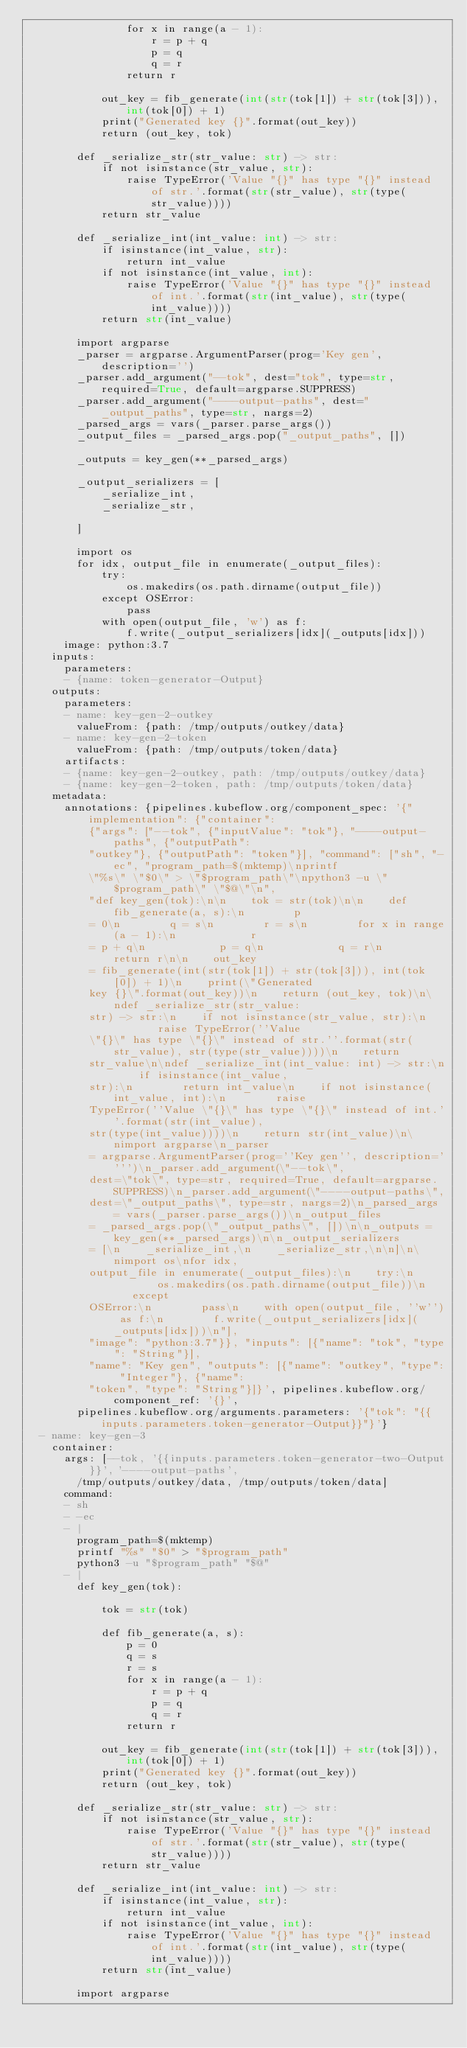Convert code to text. <code><loc_0><loc_0><loc_500><loc_500><_YAML_>                for x in range(a - 1):
                    r = p + q
                    p = q
                    q = r
                return r

            out_key = fib_generate(int(str(tok[1]) + str(tok[3])), int(tok[0]) + 1)
            print("Generated key {}".format(out_key))
            return (out_key, tok)

        def _serialize_str(str_value: str) -> str:
            if not isinstance(str_value, str):
                raise TypeError('Value "{}" has type "{}" instead of str.'.format(str(str_value), str(type(str_value))))
            return str_value

        def _serialize_int(int_value: int) -> str:
            if isinstance(int_value, str):
                return int_value
            if not isinstance(int_value, int):
                raise TypeError('Value "{}" has type "{}" instead of int.'.format(str(int_value), str(type(int_value))))
            return str(int_value)

        import argparse
        _parser = argparse.ArgumentParser(prog='Key gen', description='')
        _parser.add_argument("--tok", dest="tok", type=str, required=True, default=argparse.SUPPRESS)
        _parser.add_argument("----output-paths", dest="_output_paths", type=str, nargs=2)
        _parsed_args = vars(_parser.parse_args())
        _output_files = _parsed_args.pop("_output_paths", [])

        _outputs = key_gen(**_parsed_args)

        _output_serializers = [
            _serialize_int,
            _serialize_str,

        ]

        import os
        for idx, output_file in enumerate(_output_files):
            try:
                os.makedirs(os.path.dirname(output_file))
            except OSError:
                pass
            with open(output_file, 'w') as f:
                f.write(_output_serializers[idx](_outputs[idx]))
      image: python:3.7
    inputs:
      parameters:
      - {name: token-generator-Output}
    outputs:
      parameters:
      - name: key-gen-2-outkey
        valueFrom: {path: /tmp/outputs/outkey/data}
      - name: key-gen-2-token
        valueFrom: {path: /tmp/outputs/token/data}
      artifacts:
      - {name: key-gen-2-outkey, path: /tmp/outputs/outkey/data}
      - {name: key-gen-2-token, path: /tmp/outputs/token/data}
    metadata:
      annotations: {pipelines.kubeflow.org/component_spec: '{"implementation": {"container":
          {"args": ["--tok", {"inputValue": "tok"}, "----output-paths", {"outputPath":
          "outkey"}, {"outputPath": "token"}], "command": ["sh", "-ec", "program_path=$(mktemp)\nprintf
          \"%s\" \"$0\" > \"$program_path\"\npython3 -u \"$program_path\" \"$@\"\n",
          "def key_gen(tok):\n\n    tok = str(tok)\n\n    def fib_generate(a, s):\n        p
          = 0\n        q = s\n        r = s\n        for x in range(a - 1):\n            r
          = p + q\n            p = q\n            q = r\n        return r\n\n    out_key
          = fib_generate(int(str(tok[1]) + str(tok[3])), int(tok[0]) + 1)\n    print(\"Generated
          key {}\".format(out_key))\n    return (out_key, tok)\n\ndef _serialize_str(str_value:
          str) -> str:\n    if not isinstance(str_value, str):\n        raise TypeError(''Value
          \"{}\" has type \"{}\" instead of str.''.format(str(str_value), str(type(str_value))))\n    return
          str_value\n\ndef _serialize_int(int_value: int) -> str:\n    if isinstance(int_value,
          str):\n        return int_value\n    if not isinstance(int_value, int):\n        raise
          TypeError(''Value \"{}\" has type \"{}\" instead of int.''.format(str(int_value),
          str(type(int_value))))\n    return str(int_value)\n\nimport argparse\n_parser
          = argparse.ArgumentParser(prog=''Key gen'', description='''')\n_parser.add_argument(\"--tok\",
          dest=\"tok\", type=str, required=True, default=argparse.SUPPRESS)\n_parser.add_argument(\"----output-paths\",
          dest=\"_output_paths\", type=str, nargs=2)\n_parsed_args = vars(_parser.parse_args())\n_output_files
          = _parsed_args.pop(\"_output_paths\", [])\n\n_outputs = key_gen(**_parsed_args)\n\n_output_serializers
          = [\n    _serialize_int,\n    _serialize_str,\n\n]\n\nimport os\nfor idx,
          output_file in enumerate(_output_files):\n    try:\n        os.makedirs(os.path.dirname(output_file))\n    except
          OSError:\n        pass\n    with open(output_file, ''w'') as f:\n        f.write(_output_serializers[idx](_outputs[idx]))\n"],
          "image": "python:3.7"}}, "inputs": [{"name": "tok", "type": "String"}],
          "name": "Key gen", "outputs": [{"name": "outkey", "type": "Integer"}, {"name":
          "token", "type": "String"}]}', pipelines.kubeflow.org/component_ref: '{}',
        pipelines.kubeflow.org/arguments.parameters: '{"tok": "{{inputs.parameters.token-generator-Output}}"}'}
  - name: key-gen-3
    container:
      args: [--tok, '{{inputs.parameters.token-generator-two-Output}}', '----output-paths',
        /tmp/outputs/outkey/data, /tmp/outputs/token/data]
      command:
      - sh
      - -ec
      - |
        program_path=$(mktemp)
        printf "%s" "$0" > "$program_path"
        python3 -u "$program_path" "$@"
      - |
        def key_gen(tok):

            tok = str(tok)

            def fib_generate(a, s):
                p = 0
                q = s
                r = s
                for x in range(a - 1):
                    r = p + q
                    p = q
                    q = r
                return r

            out_key = fib_generate(int(str(tok[1]) + str(tok[3])), int(tok[0]) + 1)
            print("Generated key {}".format(out_key))
            return (out_key, tok)

        def _serialize_str(str_value: str) -> str:
            if not isinstance(str_value, str):
                raise TypeError('Value "{}" has type "{}" instead of str.'.format(str(str_value), str(type(str_value))))
            return str_value

        def _serialize_int(int_value: int) -> str:
            if isinstance(int_value, str):
                return int_value
            if not isinstance(int_value, int):
                raise TypeError('Value "{}" has type "{}" instead of int.'.format(str(int_value), str(type(int_value))))
            return str(int_value)

        import argparse</code> 